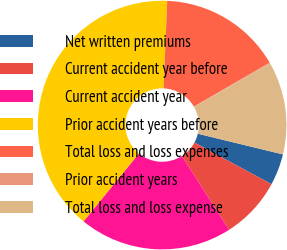<chart> <loc_0><loc_0><loc_500><loc_500><pie_chart><fcel>Net written premiums<fcel>Current accident year before<fcel>Current accident year<fcel>Prior accident years before<fcel>Total loss and loss expenses<fcel>Prior accident years<fcel>Total loss and loss expense<nl><fcel>4.1%<fcel>8.06%<fcel>19.94%<fcel>39.75%<fcel>15.98%<fcel>0.14%<fcel>12.02%<nl></chart> 